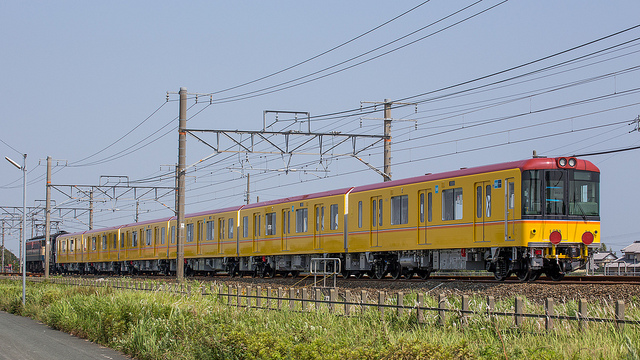<image>Is there graffiti on the train? No, there is no graffiti on the train. Is there graffiti on the train? There is no graffiti on the train. 